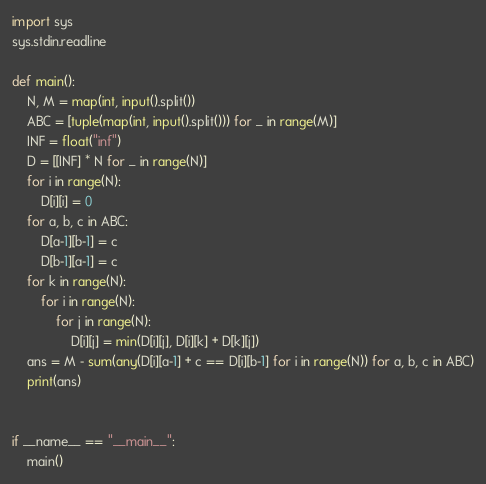Convert code to text. <code><loc_0><loc_0><loc_500><loc_500><_Python_>import sys
sys.stdin.readline

def main():
    N, M = map(int, input().split())
    ABC = [tuple(map(int, input().split())) for _ in range(M)]
    INF = float("inf")
    D = [[INF] * N for _ in range(N)]
    for i in range(N):
        D[i][i] = 0
    for a, b, c in ABC:
        D[a-1][b-1] = c
        D[b-1][a-1] = c
    for k in range(N):
        for i in range(N):
            for j in range(N):
                D[i][j] = min(D[i][j], D[i][k] + D[k][j])
    ans = M - sum(any(D[i][a-1] + c == D[i][b-1] for i in range(N)) for a, b, c in ABC)
    print(ans)


if __name__ == "__main__":
    main()</code> 